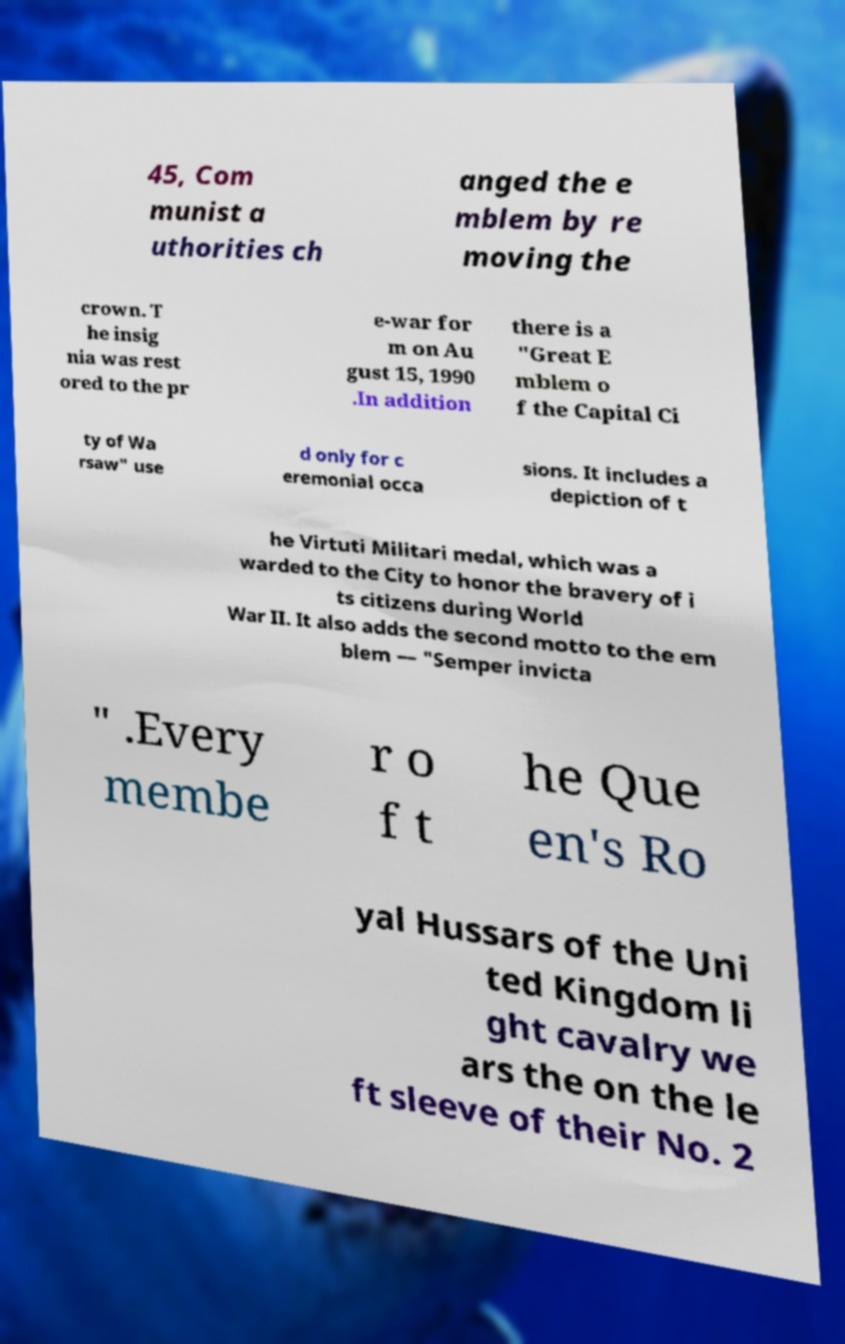There's text embedded in this image that I need extracted. Can you transcribe it verbatim? 45, Com munist a uthorities ch anged the e mblem by re moving the crown. T he insig nia was rest ored to the pr e-war for m on Au gust 15, 1990 .In addition there is a "Great E mblem o f the Capital Ci ty of Wa rsaw" use d only for c eremonial occa sions. It includes a depiction of t he Virtuti Militari medal, which was a warded to the City to honor the bravery of i ts citizens during World War II. It also adds the second motto to the em blem — "Semper invicta " .Every membe r o f t he Que en's Ro yal Hussars of the Uni ted Kingdom li ght cavalry we ars the on the le ft sleeve of their No. 2 